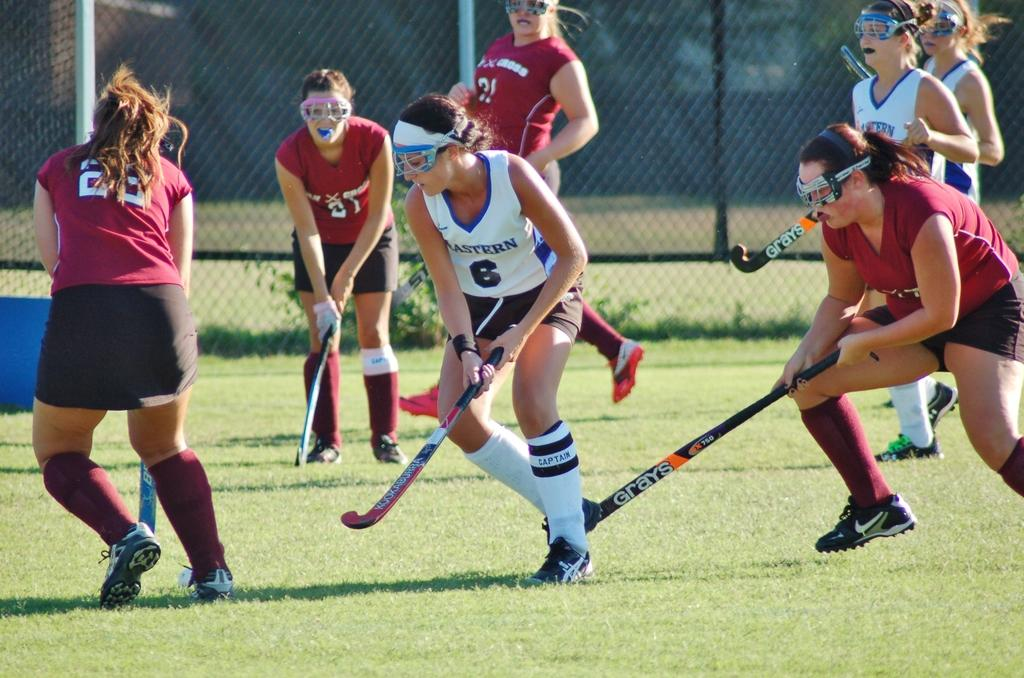What sport are the ladies playing in the image? The ladies are playing hockey in the image. What type of surface is visible at the bottom of the image? There is grass at the bottom of the image. What can be seen in the background of the image? There is a mesh in the background of the image. What type of cloth is being used to cover the pot in the image? There is no pot or cloth present in the image. What is the condition of the grass at the bottom of the image? The condition of the grass cannot be determined from the image alone, as it only provides a visual representation of the grass. 